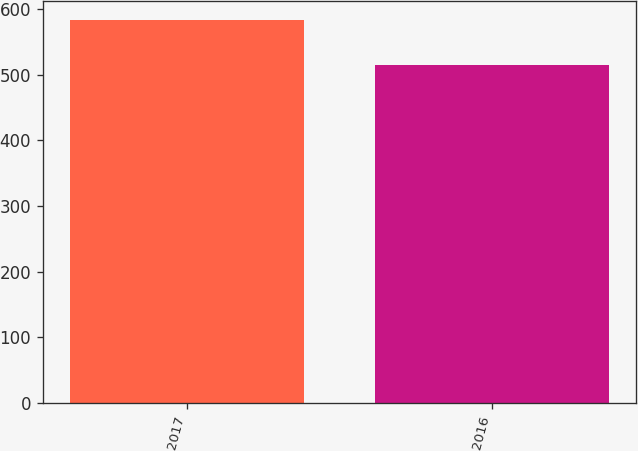Convert chart to OTSL. <chart><loc_0><loc_0><loc_500><loc_500><bar_chart><fcel>2017<fcel>2016<nl><fcel>583<fcel>514<nl></chart> 